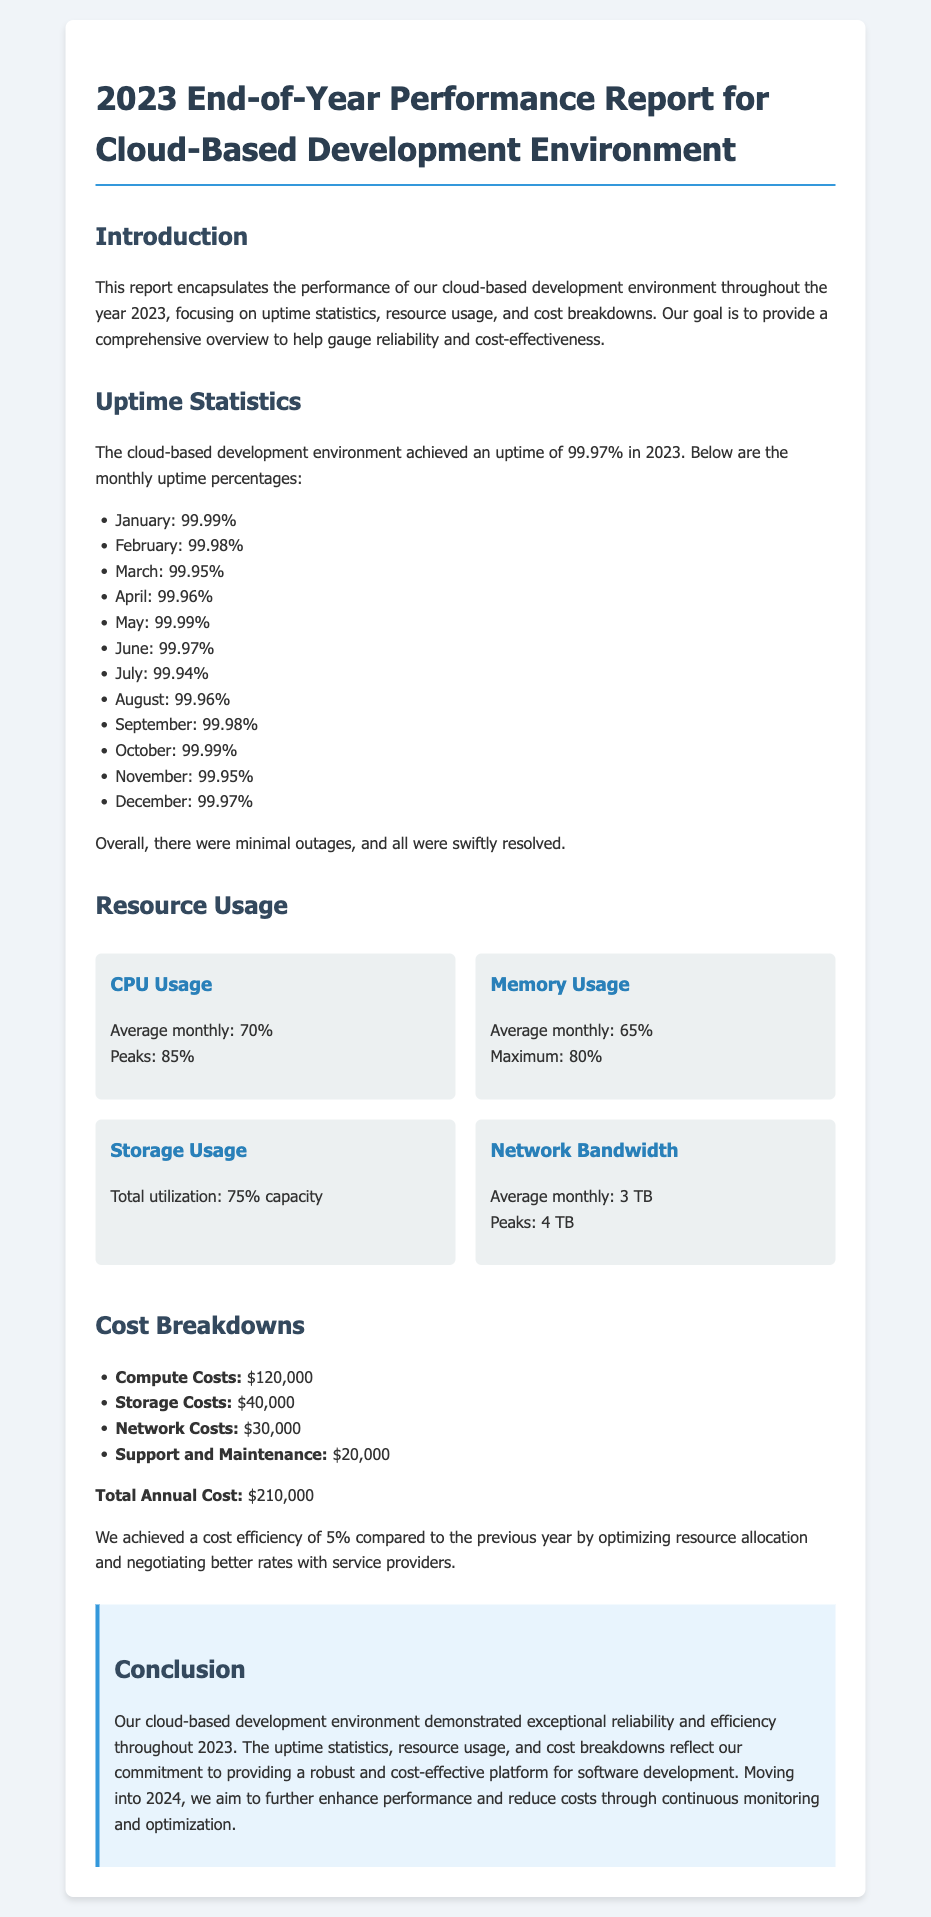What was the overall uptime percentage for 2023? The overall uptime percentage for 2023 is stated in the document as 99.97%.
Answer: 99.97% What was the peak CPU usage? The document mentions that the peak CPU usage was 85%.
Answer: 85% How much were the storage costs? Storage costs are explicitly listed in the document as $40,000.
Answer: $40,000 In which month was the lowest uptime recorded? By reviewing the monthly uptime percentages, March had the lowest uptime at 99.95%.
Answer: March What is the total annual cost for the cloud-based development environment? The total annual cost is clearly outlined in the document as $210,000.
Answer: $210,000 What percentage cost efficiency was achieved compared to the previous year? The report states a cost efficiency of 5% was achieved.
Answer: 5% What resource had an average monthly usage of 3 TB? The document indicates that the average monthly network bandwidth usage was 3 TB.
Answer: Network Bandwidth What is the focus of the performance report? The report focuses on uptime statistics, resource usage, and cost breakdowns.
Answer: Uptime statistics, resource usage, and cost breakdowns What conclusion is drawn about the cloud-based development environment in 2023? The conclusion indicates that the environment demonstrated exceptional reliability and efficiency.
Answer: Exceptional reliability and efficiency 